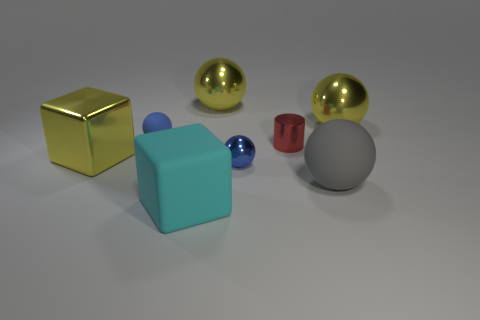There is a rubber sphere that is on the right side of the tiny blue rubber sphere; does it have the same size as the matte ball that is to the left of the matte block?
Offer a very short reply. No. What is the material of the other blue object that is the same shape as the blue shiny thing?
Ensure brevity in your answer.  Rubber. What number of large objects are either yellow objects or blue matte things?
Keep it short and to the point. 3. What material is the gray sphere?
Keep it short and to the point. Rubber. The object that is both in front of the small blue metal ball and behind the big cyan matte cube is made of what material?
Give a very brief answer. Rubber. Is the color of the big shiny cube the same as the large rubber object that is on the right side of the large cyan rubber thing?
Your response must be concise. No. There is a red thing that is the same size as the blue shiny object; what material is it?
Ensure brevity in your answer.  Metal. Are there any cyan things that have the same material as the large cyan cube?
Your answer should be compact. No. How many large yellow objects are there?
Your response must be concise. 3. Does the cyan block have the same material as the yellow object in front of the tiny cylinder?
Make the answer very short. No. 